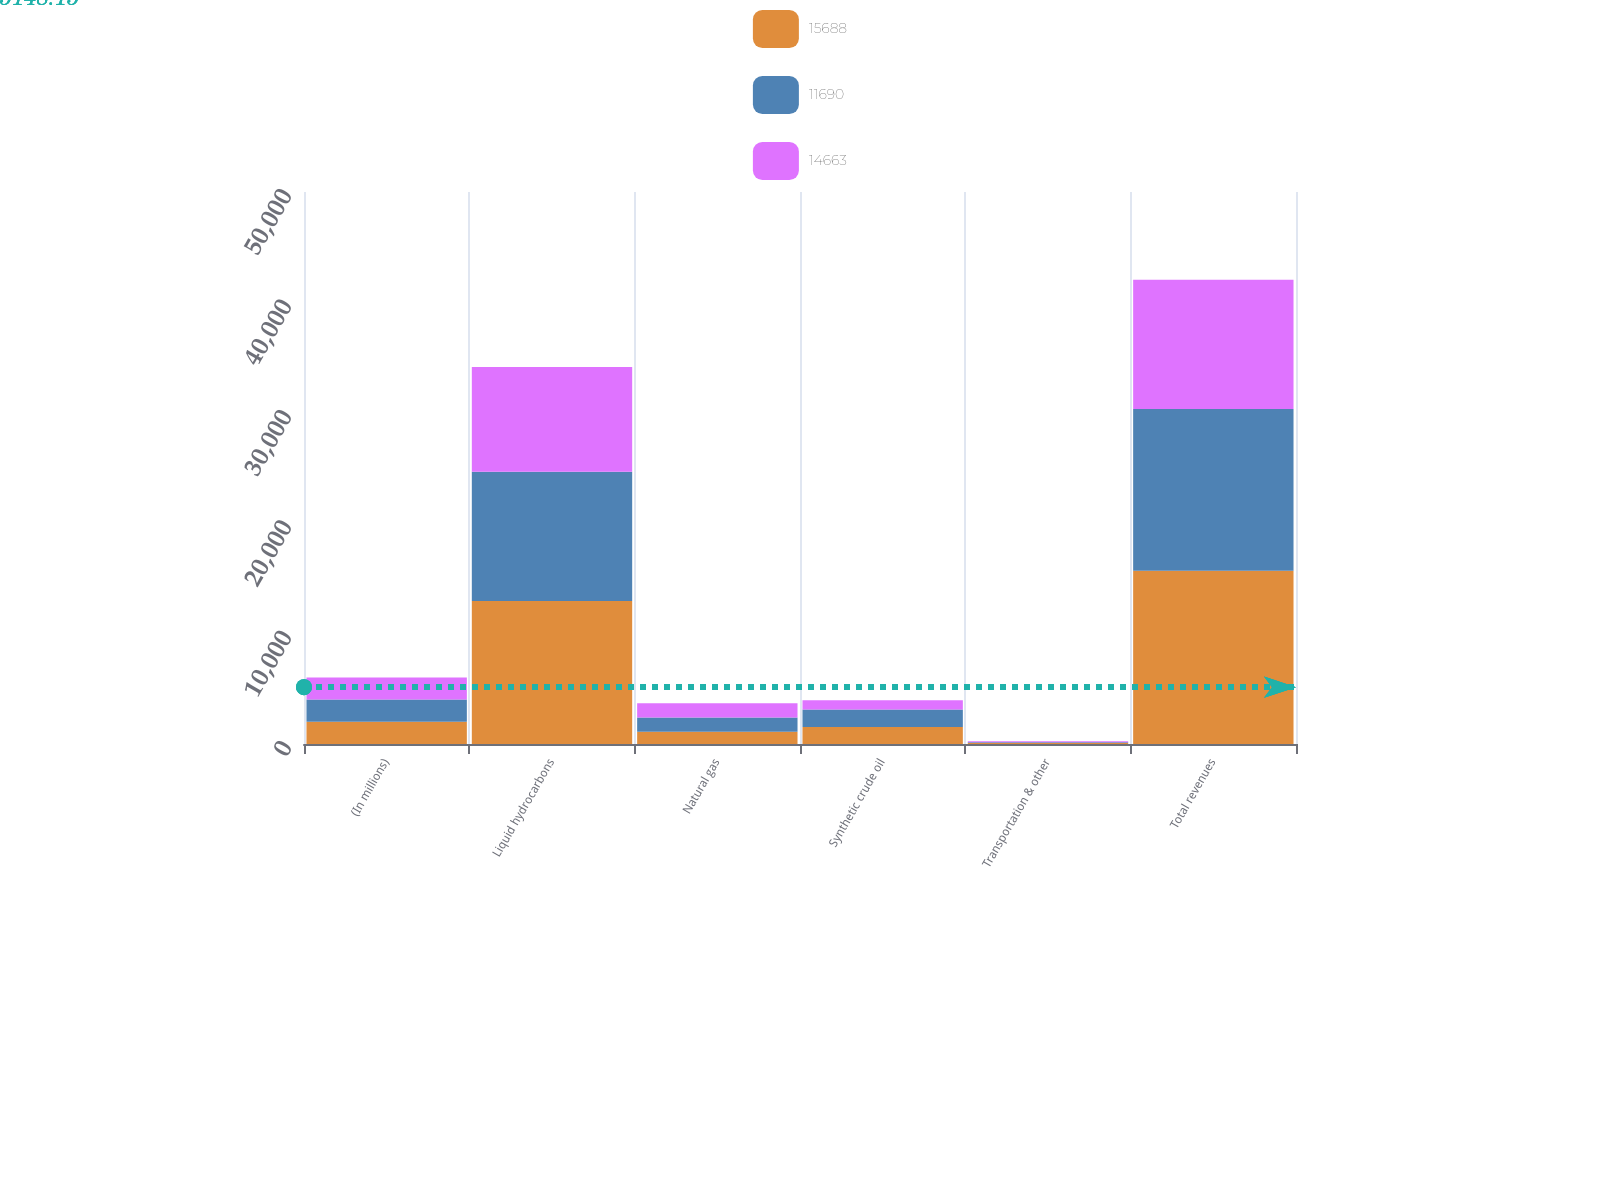Convert chart to OTSL. <chart><loc_0><loc_0><loc_500><loc_500><stacked_bar_chart><ecel><fcel>(In millions)<fcel>Liquid hydrocarbons<fcel>Natural gas<fcel>Synthetic crude oil<fcel>Transportation & other<fcel>Total revenues<nl><fcel>15688<fcel>2012<fcel>12945<fcel>1103<fcel>1545<fcel>95<fcel>15688<nl><fcel>11690<fcel>2011<fcel>11717<fcel>1291<fcel>1581<fcel>74<fcel>14663<nl><fcel>14663<fcel>2010<fcel>9480<fcel>1295<fcel>832<fcel>83<fcel>11690<nl></chart> 